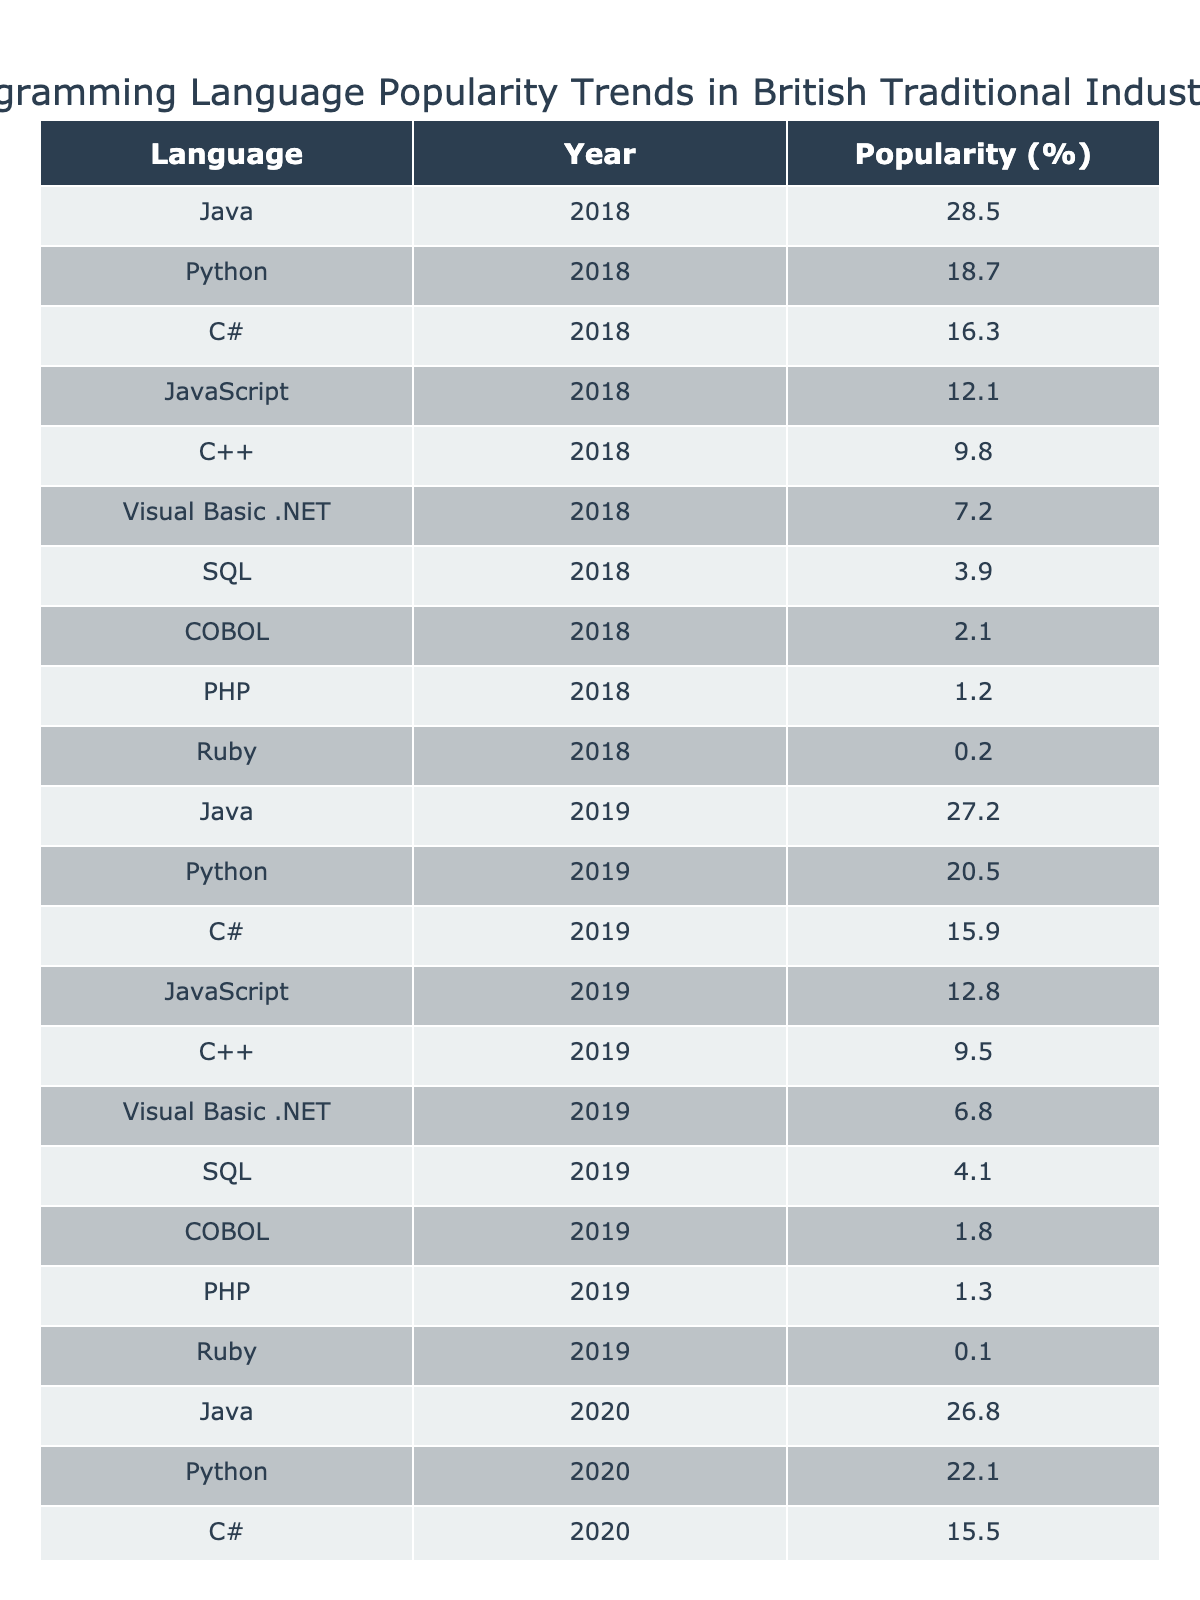What was the popularity percentage of Python in 2022? In the table, the entry for Python under the year 2022 shows a popularity of 26.5%.
Answer: 26.5% Which programming language had the highest popularity in 2018? Referring to the table, in 2018, Java had the highest popularity percentage at 28.5%.
Answer: Java What is the average popularity of C# over the years 2018 to 2022? To calculate the average, sum the popularity values for C# (16.3 + 15.9 + 15.5 + 15.2 + 14.8 = 78.7) and divide by the number of years (5). The average is 78.7 / 5 = 15.74%.
Answer: 15.74% Did the popularity of COBOL increase from 2018 to 2022? By examining the values for COBOL in 2018 (2.1%) and 2022 (0.9%), it is clear that the popularity decreased.
Answer: No What was the change in popularity of Java from 2018 to 2022? Compare the popularity of Java in 2018 (28.5%) and in 2022 (24.3%). The change is a decrease of 4.2 percentage points (28.5 - 24.3 = 4.2).
Answer: Decreased by 4.2 points Which programming language experienced the highest increase in popularity between 2018 and 2022? Calculate the change in popularity for each language from 2018 to 2022. Python had an increase of (26.5 - 18.7 = 7.8), which is the highest compared to others.
Answer: Python What percentage of the popularity was held by SQL in 2021? Looking at the table, SQL's popularity in 2021 is listed as 4.5%.
Answer: 4.5% Is Visual Basic .NET still popular in 2022? By observing the 2022 figure for Visual Basic .NET, which is 5.4%, we find that it still has a presence, albeit low.
Answer: Yes Which languages had a popularity of less than 5% in 2022? Reviewing the data for 2022, the languages with less than 5% popularity are SQL (4.7%), COBOL (0.9%), PHP (1.6%), and Ruby (0.9%).
Answer: SQL, COBOL, PHP, Ruby How much more popular was JavaScript than C++ in 2022? Check the popularity for JavaScript in 2022 (14.9%) and C++ (8.7%). The difference is 14.9 - 8.7 = 6.2%, meaning JavaScript was more popular by that amount.
Answer: 6.2% What trend do you notice for the language C# over the five years? Reviewing the values from 2018 to 2022, C# shows a consistent decrease from 16.3% to 14.8%, indicating a downward trend in popularity over the five years.
Answer: Downward trend 